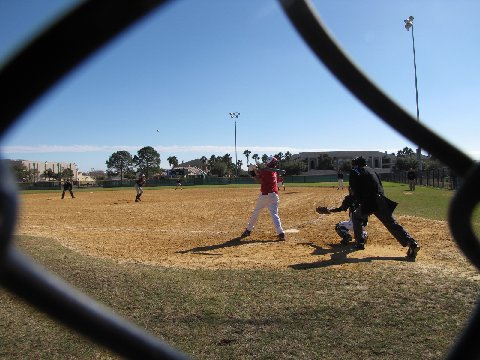What does the setting reveal about the atmosphere of the game? The setting is an open field with the sun casting a gentle glow over the neatly raked dirt and lush green outfield. There is an aura of community spirit, with the wide expanse of the field reflecting the open, encouraging nature of little league games. The distant background with minimal audience suggests an informal, local game focused more on the experience than the spectatorship. 